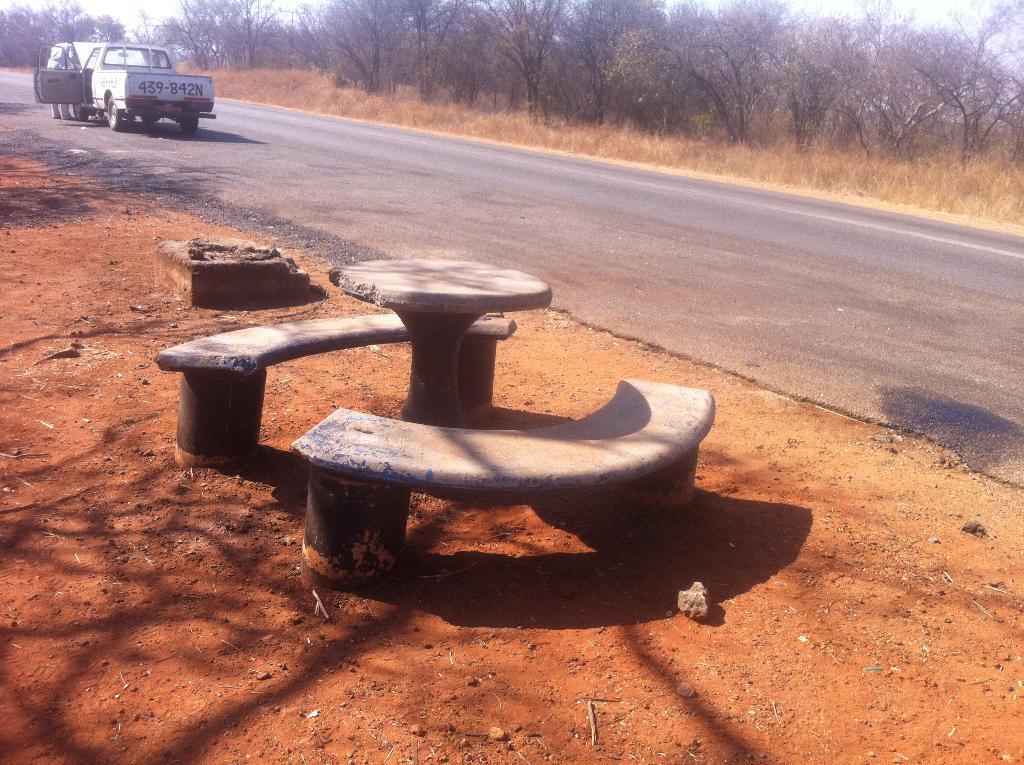Could you give a brief overview of what you see in this image? In this image there are trees truncated towards the top of the image, there are trees truncated towards the right of the image, there are trees truncated towards the left of the image, there is the grass, there is road, there is a vehicle on the road, there is a person standing on the road, there are benches made of stone, there is a table made of stone, there is the soil, there is a stone. 